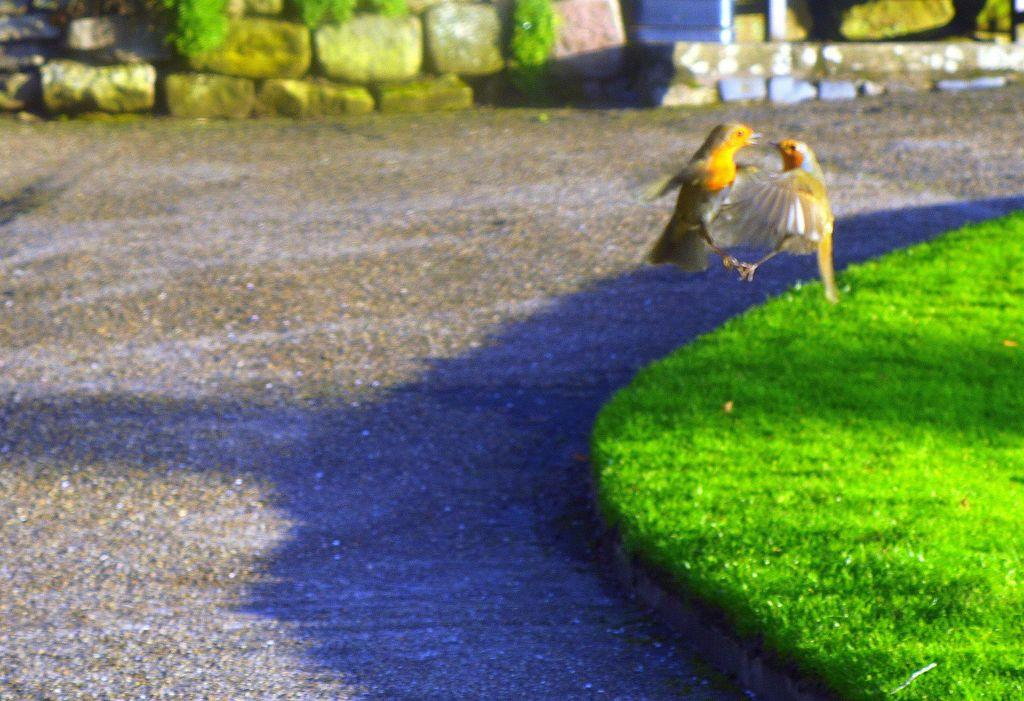What animals can be seen in the image? There are two birds flying in the air. What is located at the bottom of the image? There is a road and grass at the bottom of the image. What type of terrain is visible at the top of the image? There are stones visible at the top of the image. What type of toys can be seen in the image? There are no toys present in the image. Is there a bear visible in the image? There is no bear present in the image. 